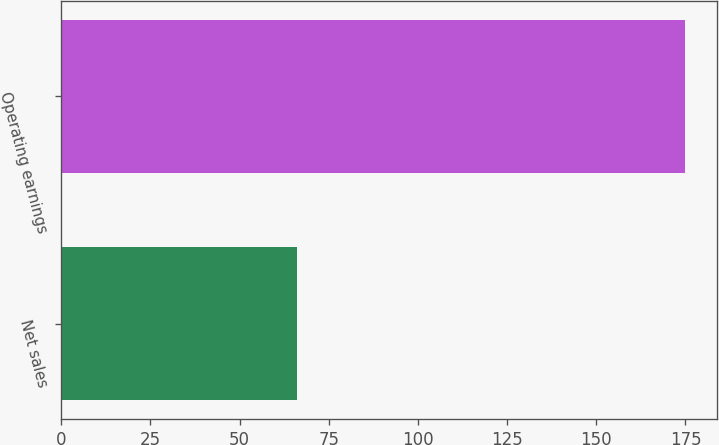Convert chart. <chart><loc_0><loc_0><loc_500><loc_500><bar_chart><fcel>Net sales<fcel>Operating earnings<nl><fcel>66<fcel>175<nl></chart> 